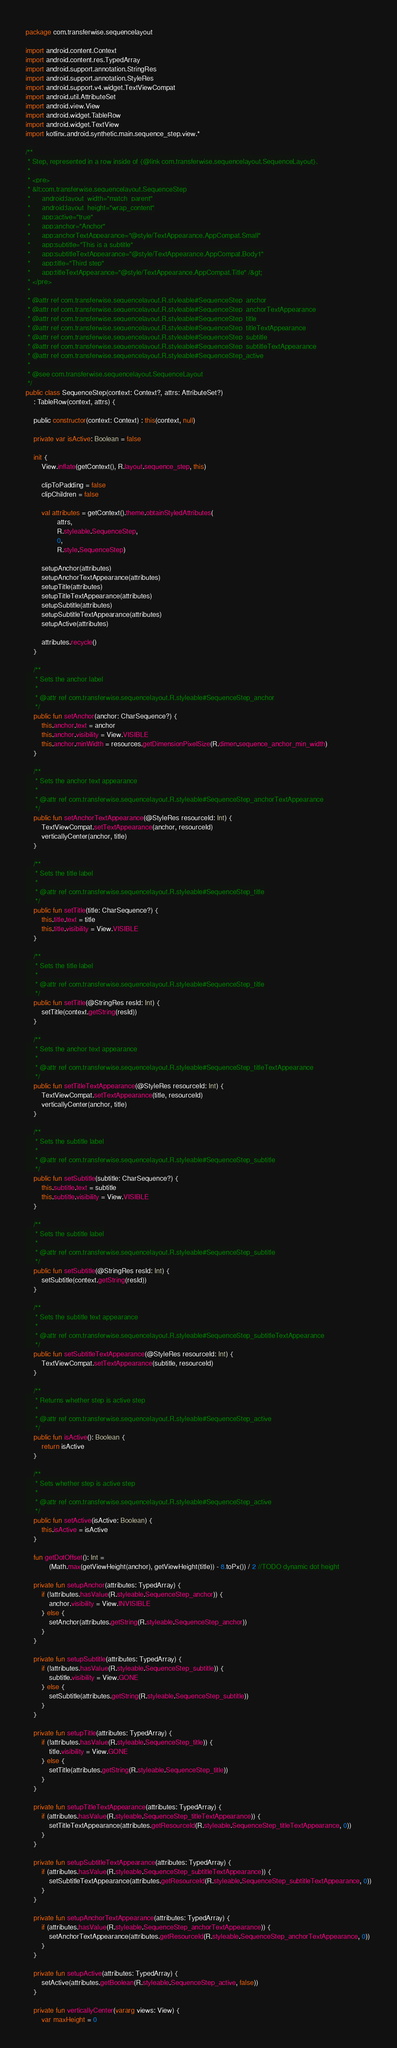<code> <loc_0><loc_0><loc_500><loc_500><_Kotlin_>package com.transferwise.sequencelayout

import android.content.Context
import android.content.res.TypedArray
import android.support.annotation.StringRes
import android.support.annotation.StyleRes
import android.support.v4.widget.TextViewCompat
import android.util.AttributeSet
import android.view.View
import android.widget.TableRow
import android.widget.TextView
import kotlinx.android.synthetic.main.sequence_step.view.*

/**
 * Step, represented in a row inside of {@link com.transferwise.sequencelayout.SequenceLayout}.
 *
 * <pre>
 * &lt;com.transferwise.sequencelayout.SequenceStep
 *      android:layout_width="match_parent"
 *      android:layout_height="wrap_content"
 *      app:active="true"
 *      app:anchor="Anchor"
 *      app:anchorTextAppearance="@style/TextAppearance.AppCompat.Small"
 *      app:subtitle="This is a subtitle"
 *      app:subtitleTextAppearance="@style/TextAppearance.AppCompat.Body1"
 *      app:title="Third step"
 *      app:titleTextAppearance="@style/TextAppearance.AppCompat.Title" /&gt;
 * </pre>
 *
 * @attr ref com.transferwise.sequencelayout.R.styleable#SequenceStep_anchor
 * @attr ref com.transferwise.sequencelayout.R.styleable#SequenceStep_anchorTextAppearance
 * @attr ref com.transferwise.sequencelayout.R.styleable#SequenceStep_title
 * @attr ref com.transferwise.sequencelayout.R.styleable#SequenceStep_titleTextAppearance
 * @attr ref com.transferwise.sequencelayout.R.styleable#SequenceStep_subtitle
 * @attr ref com.transferwise.sequencelayout.R.styleable#SequenceStep_subtitleTextAppearance
 * @attr ref com.transferwise.sequencelayout.R.styleable#SequenceStep_active
 *
 * @see com.transferwise.sequencelayout.SequenceLayout
 */
public class SequenceStep(context: Context?, attrs: AttributeSet?)
    : TableRow(context, attrs) {

    public constructor(context: Context) : this(context, null)

    private var isActive: Boolean = false

    init {
        View.inflate(getContext(), R.layout.sequence_step, this)

        clipToPadding = false
        clipChildren = false

        val attributes = getContext().theme.obtainStyledAttributes(
                attrs,
                R.styleable.SequenceStep,
                0,
                R.style.SequenceStep)

        setupAnchor(attributes)
        setupAnchorTextAppearance(attributes)
        setupTitle(attributes)
        setupTitleTextAppearance(attributes)
        setupSubtitle(attributes)
        setupSubtitleTextAppearance(attributes)
        setupActive(attributes)

        attributes.recycle()
    }

    /**
     * Sets the anchor label
     *
     * @attr ref com.transferwise.sequencelayout.R.styleable#SequenceStep_anchor
     */
    public fun setAnchor(anchor: CharSequence?) {
        this.anchor.text = anchor
        this.anchor.visibility = View.VISIBLE
        this.anchor.minWidth = resources.getDimensionPixelSize(R.dimen.sequence_anchor_min_width)
    }

    /**
     * Sets the anchor text appearance
     *
     * @attr ref com.transferwise.sequencelayout.R.styleable#SequenceStep_anchorTextAppearance
     */
    public fun setAnchorTextAppearance(@StyleRes resourceId: Int) {
        TextViewCompat.setTextAppearance(anchor, resourceId)
        verticallyCenter(anchor, title)
    }

    /**
     * Sets the title label
     *
     * @attr ref com.transferwise.sequencelayout.R.styleable#SequenceStep_title
     */
    public fun setTitle(title: CharSequence?) {
        this.title.text = title
        this.title.visibility = View.VISIBLE
    }

    /**
     * Sets the title label
     *
     * @attr ref com.transferwise.sequencelayout.R.styleable#SequenceStep_title
     */
    public fun setTitle(@StringRes resId: Int) {
        setTitle(context.getString(resId))
    }

    /**
     * Sets the anchor text appearance
     *
     * @attr ref com.transferwise.sequencelayout.R.styleable#SequenceStep_titleTextAppearance
     */
    public fun setTitleTextAppearance(@StyleRes resourceId: Int) {
        TextViewCompat.setTextAppearance(title, resourceId)
        verticallyCenter(anchor, title)
    }

    /**
     * Sets the subtitle label
     *
     * @attr ref com.transferwise.sequencelayout.R.styleable#SequenceStep_subtitle
     */
    public fun setSubtitle(subtitle: CharSequence?) {
        this.subtitle.text = subtitle
        this.subtitle.visibility = View.VISIBLE
    }

    /**
     * Sets the subtitle label
     *
     * @attr ref com.transferwise.sequencelayout.R.styleable#SequenceStep_subtitle
     */
    public fun setSubtitle(@StringRes resId: Int) {
        setSubtitle(context.getString(resId))
    }

    /**
     * Sets the subtitle text appearance
     *
     * @attr ref com.transferwise.sequencelayout.R.styleable#SequenceStep_subtitleTextAppearance
     */
    public fun setSubtitleTextAppearance(@StyleRes resourceId: Int) {
        TextViewCompat.setTextAppearance(subtitle, resourceId)
    }

    /**
     * Returns whether step is active step
     *
     * @attr ref com.transferwise.sequencelayout.R.styleable#SequenceStep_active
     */
    public fun isActive(): Boolean {
        return isActive
    }

    /**
     * Sets whether step is active step
     *
     * @attr ref com.transferwise.sequencelayout.R.styleable#SequenceStep_active
     */
    public fun setActive(isActive: Boolean) {
        this.isActive = isActive
    }

    fun getDotOffset(): Int =
            (Math.max(getViewHeight(anchor), getViewHeight(title)) - 8.toPx()) / 2 //TODO dynamic dot height

    private fun setupAnchor(attributes: TypedArray) {
        if (!attributes.hasValue(R.styleable.SequenceStep_anchor)) {
            anchor.visibility = View.INVISIBLE
        } else {
            setAnchor(attributes.getString(R.styleable.SequenceStep_anchor))
        }
    }

    private fun setupSubtitle(attributes: TypedArray) {
        if (!attributes.hasValue(R.styleable.SequenceStep_subtitle)) {
            subtitle.visibility = View.GONE
        } else {
            setSubtitle(attributes.getString(R.styleable.SequenceStep_subtitle))
        }
    }

    private fun setupTitle(attributes: TypedArray) {
        if (!attributes.hasValue(R.styleable.SequenceStep_title)) {
            title.visibility = View.GONE
        } else {
            setTitle(attributes.getString(R.styleable.SequenceStep_title))
        }
    }

    private fun setupTitleTextAppearance(attributes: TypedArray) {
        if (attributes.hasValue(R.styleable.SequenceStep_titleTextAppearance)) {
            setTitleTextAppearance(attributes.getResourceId(R.styleable.SequenceStep_titleTextAppearance, 0))
        }
    }

    private fun setupSubtitleTextAppearance(attributes: TypedArray) {
        if (attributes.hasValue(R.styleable.SequenceStep_subtitleTextAppearance)) {
            setSubtitleTextAppearance(attributes.getResourceId(R.styleable.SequenceStep_subtitleTextAppearance, 0))
        }
    }

    private fun setupAnchorTextAppearance(attributes: TypedArray) {
        if (attributes.hasValue(R.styleable.SequenceStep_anchorTextAppearance)) {
            setAnchorTextAppearance(attributes.getResourceId(R.styleable.SequenceStep_anchorTextAppearance, 0))
        }
    }

    private fun setupActive(attributes: TypedArray) {
        setActive(attributes.getBoolean(R.styleable.SequenceStep_active, false))
    }

    private fun verticallyCenter(vararg views: View) {
        var maxHeight = 0</code> 